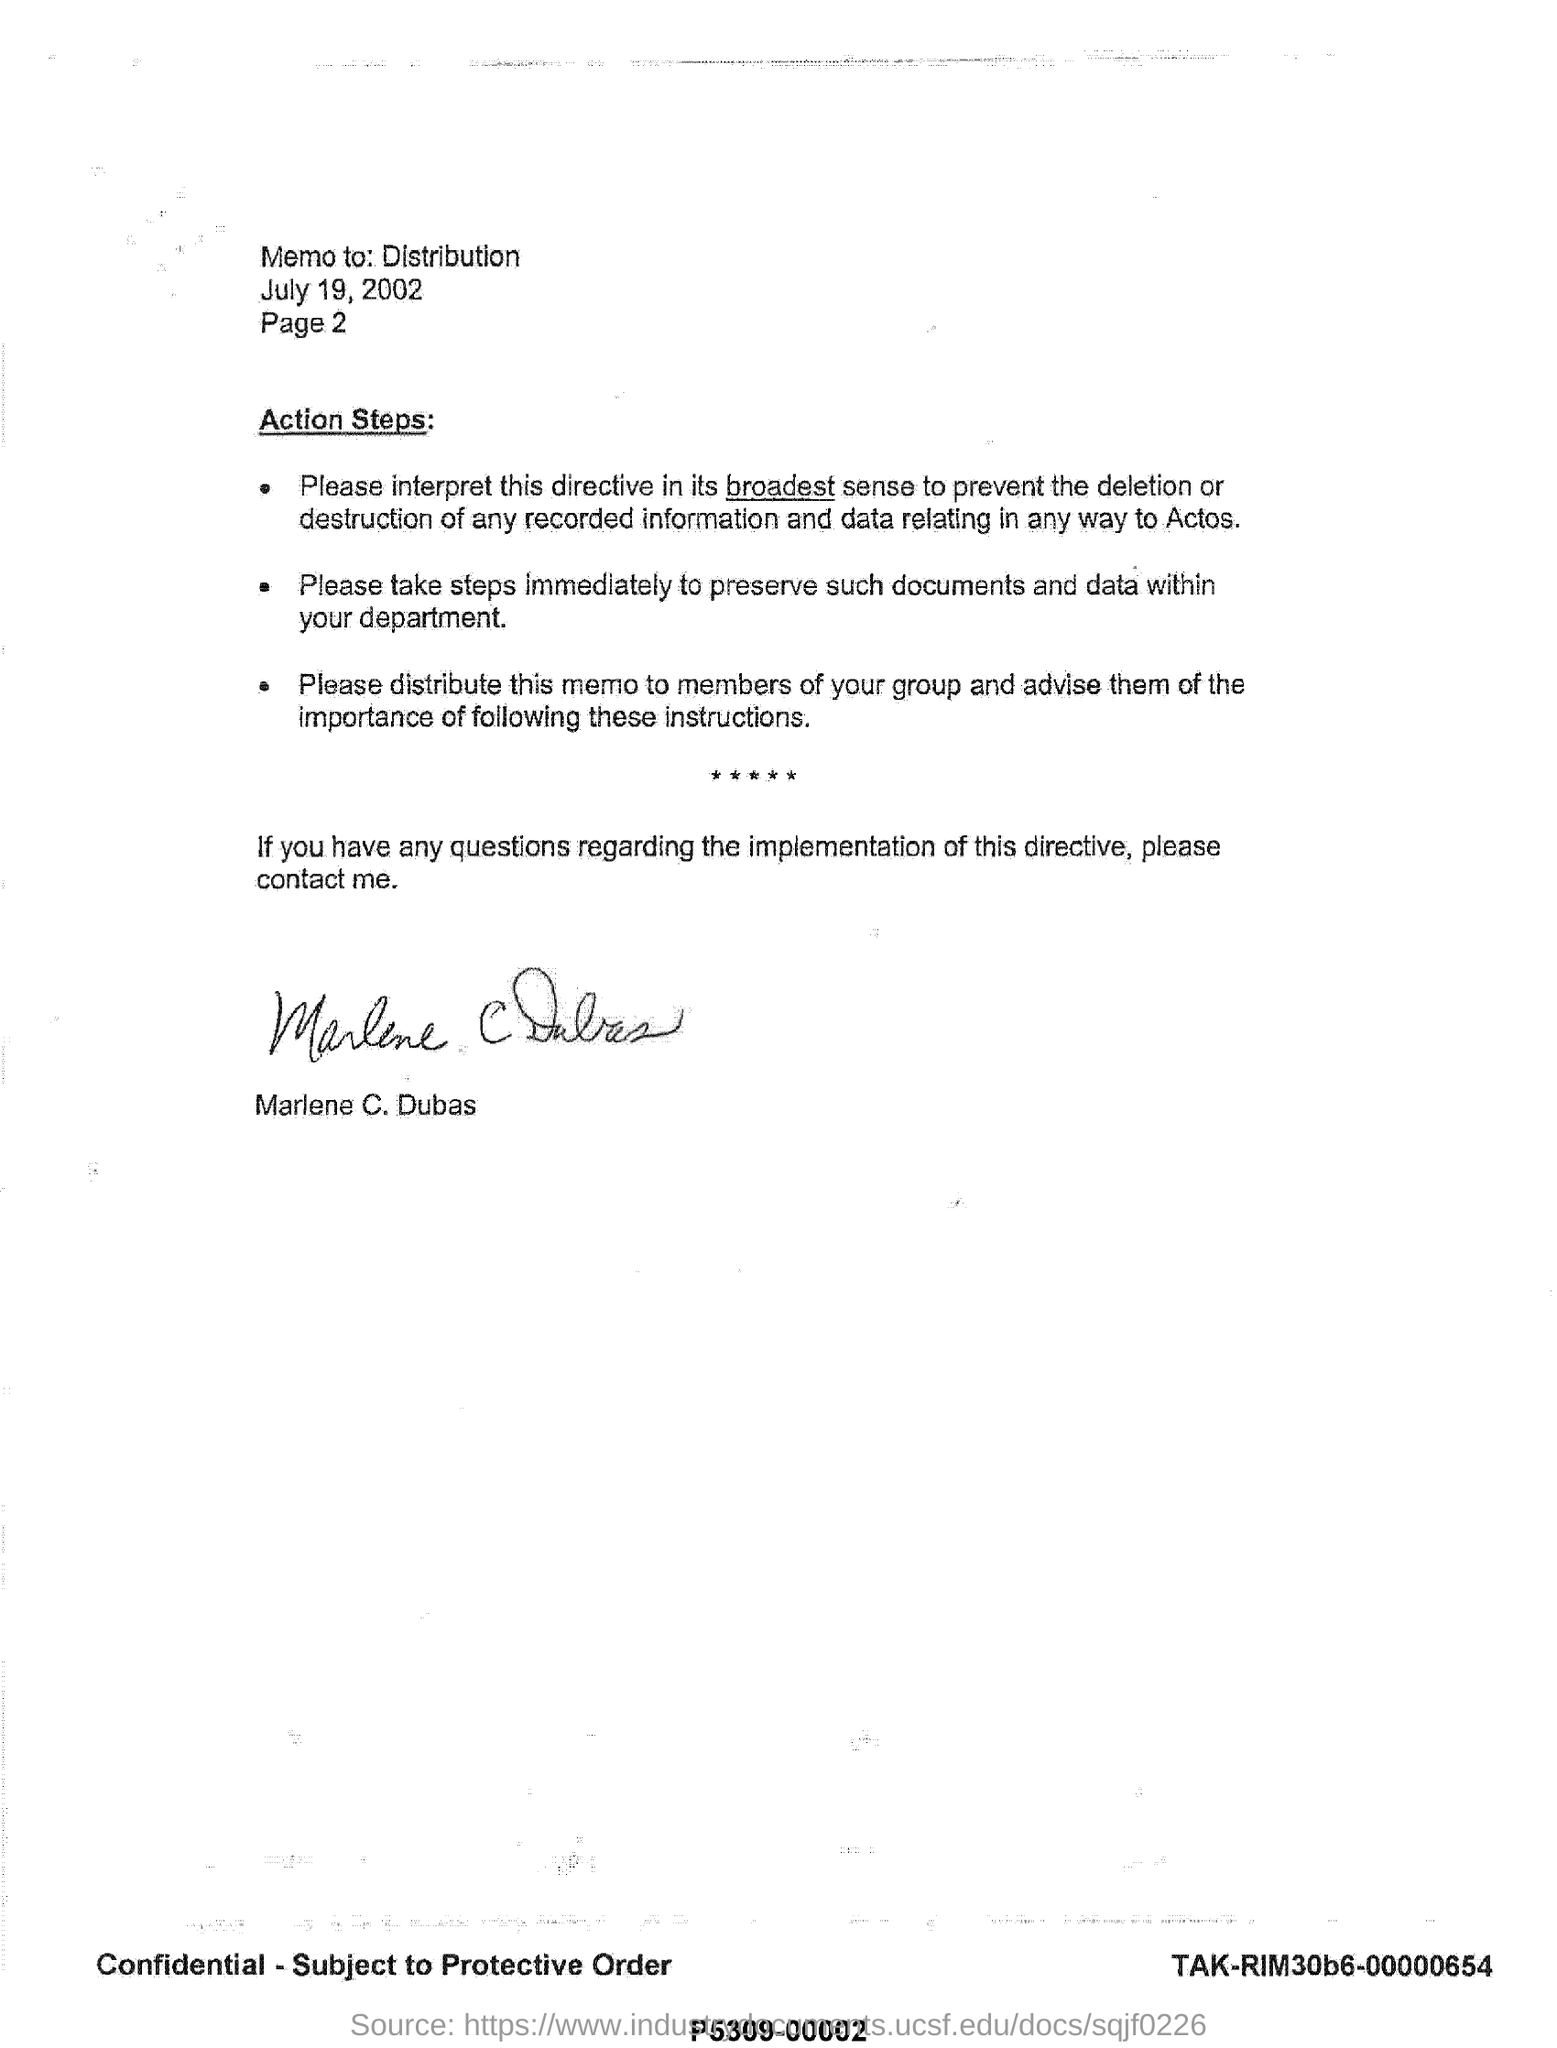List a handful of essential elements in this visual. The memo is addressed to a specific distribution list. The signature of Marlene C. Dubas is present at the bottom. The date mentioned is July 19, 2002. 